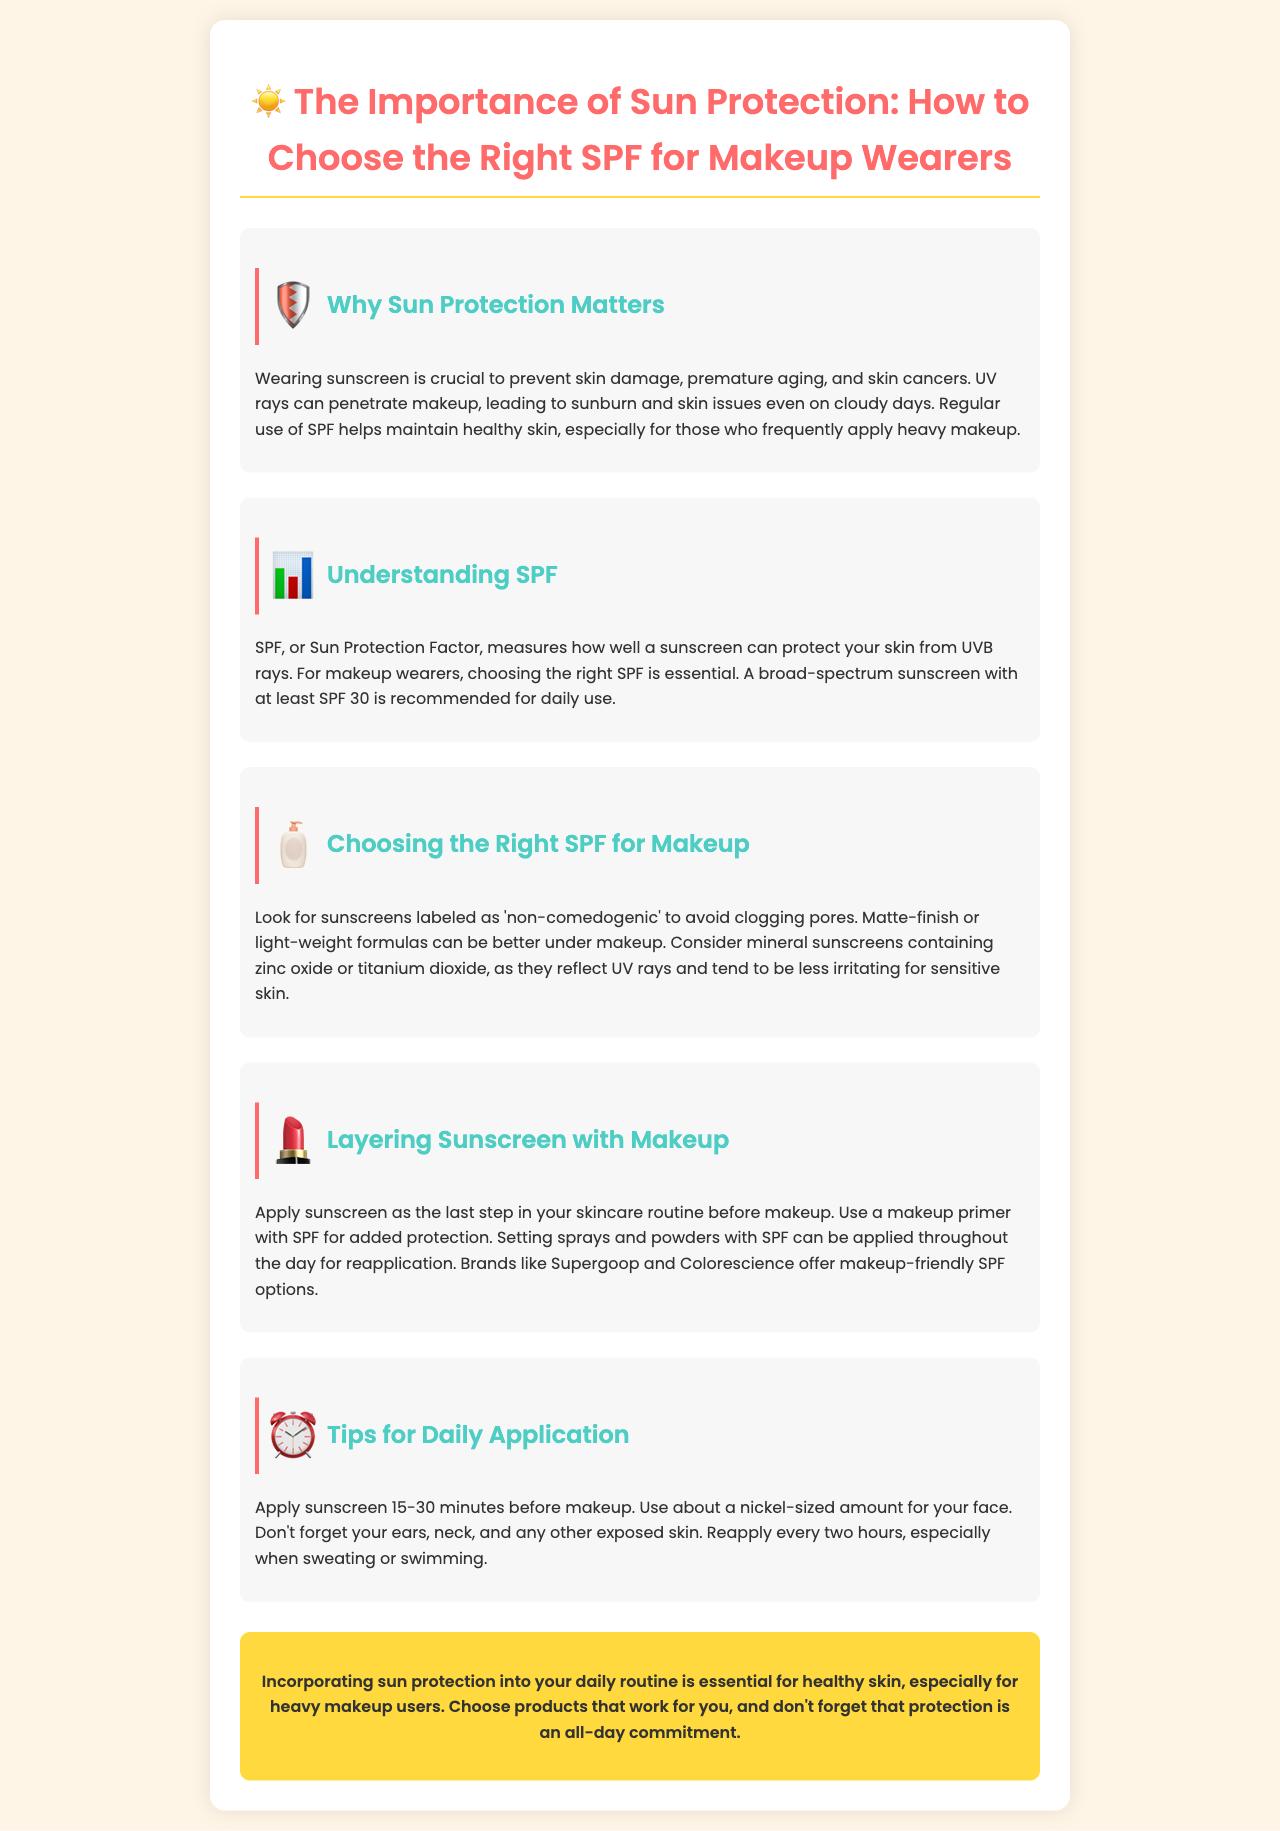What is the recommended SPF for daily use? The document suggests using a broad-spectrum sunscreen with at least SPF 30 for daily use.
Answer: SPF 30 What should makeup wearers look for in sunscreens? Sunscreens should be labeled as 'non-comedogenic' to avoid clogging pores.
Answer: Non-comedogenic What is a better finish for sunscreen under makeup? The brochure advises using matte-finish or light-weight formulas for sunscreen under makeup.
Answer: Matte-finish When should sunscreen be applied before makeup? Sunscreen should be applied 15-30 minutes before applying makeup.
Answer: 15-30 minutes Which brands offer makeup-friendly SPF options? The document mentions brands like Supergoop and Colorescience as offering makeup-friendly SPF options.
Answer: Supergoop and Colorescience What are the key areas to apply sunscreen? The key areas to apply sunscreen include the face, ears, and neck.
Answer: Face, ears, neck What ingredients in mineral sunscreens reflect UV rays? Zinc oxide and titanium dioxide are the ingredients in mineral sunscreens that reflect UV rays.
Answer: Zinc oxide or titanium dioxide What is a tip for reapplying sunscreen? The brochure states that setting sprays and powders with SPF can be applied throughout the day for reapplication.
Answer: Setting sprays and powders with SPF 